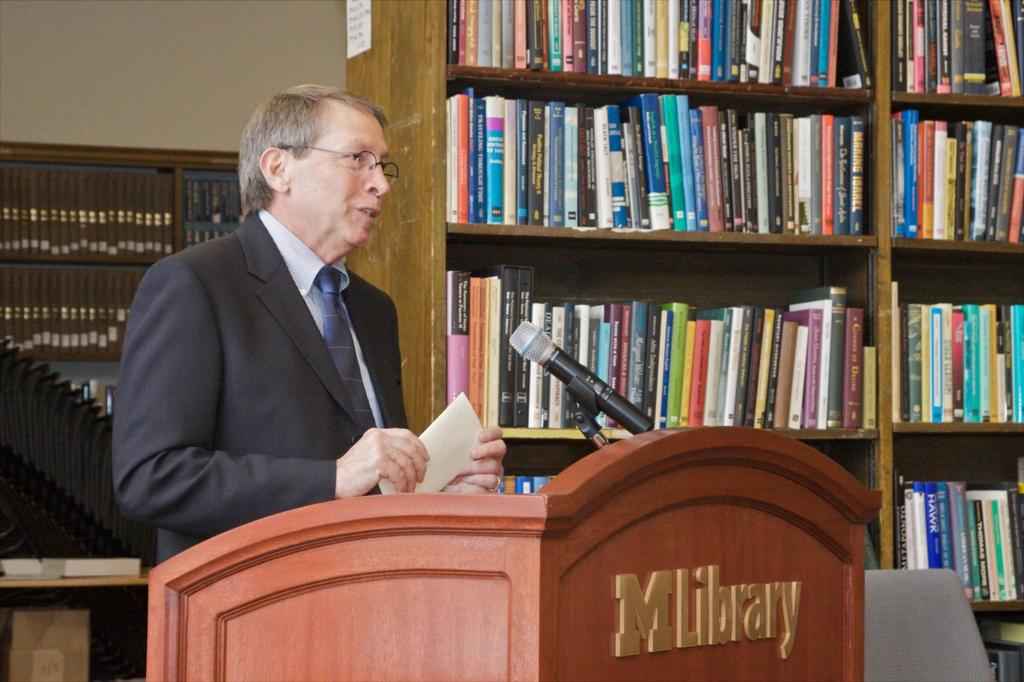Provide a one-sentence caption for the provided image. A man standing in front of a podium that says MLibrary. 